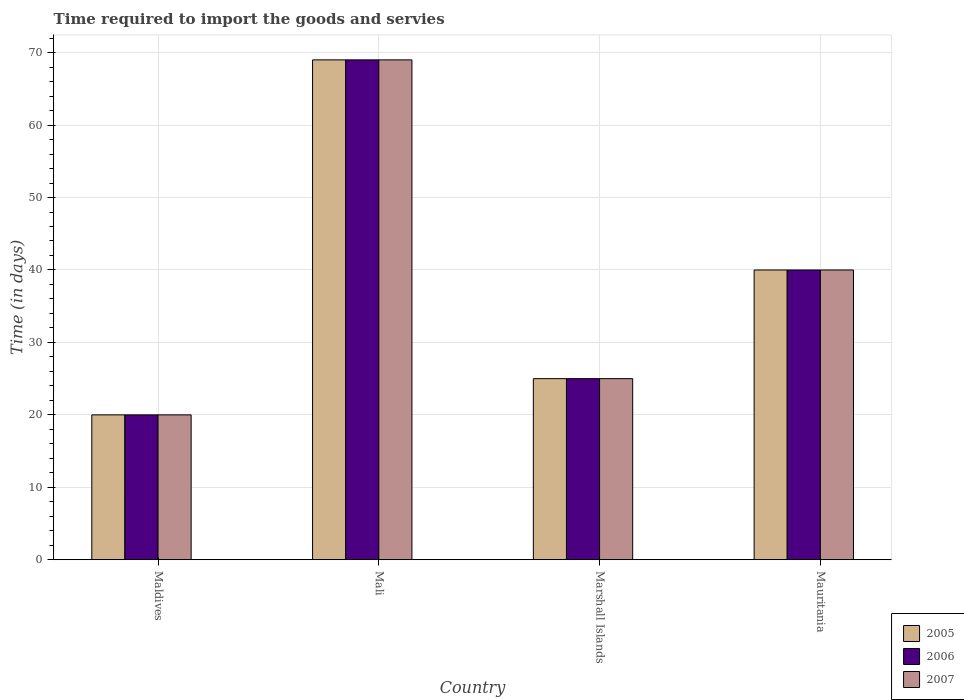How many different coloured bars are there?
Provide a short and direct response. 3. How many groups of bars are there?
Give a very brief answer. 4. Are the number of bars per tick equal to the number of legend labels?
Provide a short and direct response. Yes. How many bars are there on the 4th tick from the left?
Your answer should be compact. 3. How many bars are there on the 1st tick from the right?
Provide a succinct answer. 3. What is the label of the 1st group of bars from the left?
Make the answer very short. Maldives. In how many cases, is the number of bars for a given country not equal to the number of legend labels?
Your answer should be compact. 0. What is the number of days required to import the goods and services in 2007 in Marshall Islands?
Make the answer very short. 25. Across all countries, what is the maximum number of days required to import the goods and services in 2006?
Offer a very short reply. 69. In which country was the number of days required to import the goods and services in 2006 maximum?
Offer a very short reply. Mali. In which country was the number of days required to import the goods and services in 2006 minimum?
Provide a succinct answer. Maldives. What is the total number of days required to import the goods and services in 2006 in the graph?
Offer a terse response. 154. What is the average number of days required to import the goods and services in 2007 per country?
Keep it short and to the point. 38.5. What is the difference between the number of days required to import the goods and services of/in 2007 and number of days required to import the goods and services of/in 2006 in Mauritania?
Your answer should be compact. 0. In how many countries, is the number of days required to import the goods and services in 2006 greater than 56 days?
Make the answer very short. 1. What is the difference between the highest and the second highest number of days required to import the goods and services in 2007?
Ensure brevity in your answer.  15. What is the difference between the highest and the lowest number of days required to import the goods and services in 2006?
Ensure brevity in your answer.  49. Is the sum of the number of days required to import the goods and services in 2005 in Marshall Islands and Mauritania greater than the maximum number of days required to import the goods and services in 2006 across all countries?
Give a very brief answer. No. Is it the case that in every country, the sum of the number of days required to import the goods and services in 2005 and number of days required to import the goods and services in 2006 is greater than the number of days required to import the goods and services in 2007?
Provide a short and direct response. Yes. How many countries are there in the graph?
Ensure brevity in your answer.  4. What is the difference between two consecutive major ticks on the Y-axis?
Offer a very short reply. 10. Are the values on the major ticks of Y-axis written in scientific E-notation?
Your answer should be compact. No. How many legend labels are there?
Ensure brevity in your answer.  3. What is the title of the graph?
Ensure brevity in your answer.  Time required to import the goods and servies. Does "1984" appear as one of the legend labels in the graph?
Your answer should be compact. No. What is the label or title of the X-axis?
Make the answer very short. Country. What is the label or title of the Y-axis?
Provide a succinct answer. Time (in days). What is the Time (in days) of 2005 in Maldives?
Offer a terse response. 20. What is the Time (in days) in 2007 in Maldives?
Keep it short and to the point. 20. What is the Time (in days) of 2006 in Mali?
Make the answer very short. 69. What is the Time (in days) of 2005 in Marshall Islands?
Offer a terse response. 25. What is the Time (in days) of 2006 in Marshall Islands?
Provide a short and direct response. 25. What is the Time (in days) of 2007 in Marshall Islands?
Make the answer very short. 25. What is the Time (in days) of 2005 in Mauritania?
Your response must be concise. 40. What is the Time (in days) of 2006 in Mauritania?
Make the answer very short. 40. What is the Time (in days) of 2007 in Mauritania?
Your response must be concise. 40. Across all countries, what is the maximum Time (in days) in 2006?
Keep it short and to the point. 69. Across all countries, what is the minimum Time (in days) of 2005?
Provide a succinct answer. 20. Across all countries, what is the minimum Time (in days) in 2007?
Offer a terse response. 20. What is the total Time (in days) in 2005 in the graph?
Ensure brevity in your answer.  154. What is the total Time (in days) of 2006 in the graph?
Offer a terse response. 154. What is the total Time (in days) of 2007 in the graph?
Your answer should be very brief. 154. What is the difference between the Time (in days) of 2005 in Maldives and that in Mali?
Ensure brevity in your answer.  -49. What is the difference between the Time (in days) of 2006 in Maldives and that in Mali?
Offer a terse response. -49. What is the difference between the Time (in days) of 2007 in Maldives and that in Mali?
Your response must be concise. -49. What is the difference between the Time (in days) in 2006 in Maldives and that in Marshall Islands?
Give a very brief answer. -5. What is the difference between the Time (in days) of 2007 in Maldives and that in Marshall Islands?
Keep it short and to the point. -5. What is the difference between the Time (in days) of 2005 in Maldives and that in Mauritania?
Ensure brevity in your answer.  -20. What is the difference between the Time (in days) of 2006 in Maldives and that in Mauritania?
Ensure brevity in your answer.  -20. What is the difference between the Time (in days) of 2005 in Mali and that in Marshall Islands?
Give a very brief answer. 44. What is the difference between the Time (in days) in 2007 in Mali and that in Marshall Islands?
Your response must be concise. 44. What is the difference between the Time (in days) of 2007 in Marshall Islands and that in Mauritania?
Your answer should be compact. -15. What is the difference between the Time (in days) of 2005 in Maldives and the Time (in days) of 2006 in Mali?
Your response must be concise. -49. What is the difference between the Time (in days) of 2005 in Maldives and the Time (in days) of 2007 in Mali?
Offer a terse response. -49. What is the difference between the Time (in days) in 2006 in Maldives and the Time (in days) in 2007 in Mali?
Give a very brief answer. -49. What is the difference between the Time (in days) of 2005 in Maldives and the Time (in days) of 2007 in Marshall Islands?
Offer a very short reply. -5. What is the difference between the Time (in days) in 2006 in Maldives and the Time (in days) in 2007 in Marshall Islands?
Give a very brief answer. -5. What is the difference between the Time (in days) in 2005 in Maldives and the Time (in days) in 2006 in Mauritania?
Provide a short and direct response. -20. What is the difference between the Time (in days) of 2005 in Maldives and the Time (in days) of 2007 in Mauritania?
Ensure brevity in your answer.  -20. What is the difference between the Time (in days) of 2005 in Mali and the Time (in days) of 2006 in Mauritania?
Give a very brief answer. 29. What is the difference between the Time (in days) of 2006 in Mali and the Time (in days) of 2007 in Mauritania?
Your response must be concise. 29. What is the difference between the Time (in days) in 2005 in Marshall Islands and the Time (in days) in 2007 in Mauritania?
Your response must be concise. -15. What is the average Time (in days) of 2005 per country?
Give a very brief answer. 38.5. What is the average Time (in days) of 2006 per country?
Your answer should be compact. 38.5. What is the average Time (in days) of 2007 per country?
Provide a succinct answer. 38.5. What is the difference between the Time (in days) in 2006 and Time (in days) in 2007 in Maldives?
Ensure brevity in your answer.  0. What is the difference between the Time (in days) in 2005 and Time (in days) in 2006 in Mali?
Provide a short and direct response. 0. What is the difference between the Time (in days) of 2006 and Time (in days) of 2007 in Mauritania?
Ensure brevity in your answer.  0. What is the ratio of the Time (in days) of 2005 in Maldives to that in Mali?
Offer a very short reply. 0.29. What is the ratio of the Time (in days) in 2006 in Maldives to that in Mali?
Offer a very short reply. 0.29. What is the ratio of the Time (in days) in 2007 in Maldives to that in Mali?
Give a very brief answer. 0.29. What is the ratio of the Time (in days) of 2006 in Maldives to that in Marshall Islands?
Offer a very short reply. 0.8. What is the ratio of the Time (in days) of 2007 in Maldives to that in Marshall Islands?
Keep it short and to the point. 0.8. What is the ratio of the Time (in days) of 2007 in Maldives to that in Mauritania?
Provide a succinct answer. 0.5. What is the ratio of the Time (in days) of 2005 in Mali to that in Marshall Islands?
Ensure brevity in your answer.  2.76. What is the ratio of the Time (in days) of 2006 in Mali to that in Marshall Islands?
Offer a terse response. 2.76. What is the ratio of the Time (in days) in 2007 in Mali to that in Marshall Islands?
Keep it short and to the point. 2.76. What is the ratio of the Time (in days) in 2005 in Mali to that in Mauritania?
Provide a succinct answer. 1.73. What is the ratio of the Time (in days) in 2006 in Mali to that in Mauritania?
Your answer should be compact. 1.73. What is the ratio of the Time (in days) of 2007 in Mali to that in Mauritania?
Offer a terse response. 1.73. What is the ratio of the Time (in days) of 2007 in Marshall Islands to that in Mauritania?
Offer a very short reply. 0.62. What is the difference between the highest and the second highest Time (in days) in 2005?
Ensure brevity in your answer.  29. What is the difference between the highest and the second highest Time (in days) of 2007?
Give a very brief answer. 29. What is the difference between the highest and the lowest Time (in days) in 2006?
Keep it short and to the point. 49. What is the difference between the highest and the lowest Time (in days) of 2007?
Keep it short and to the point. 49. 